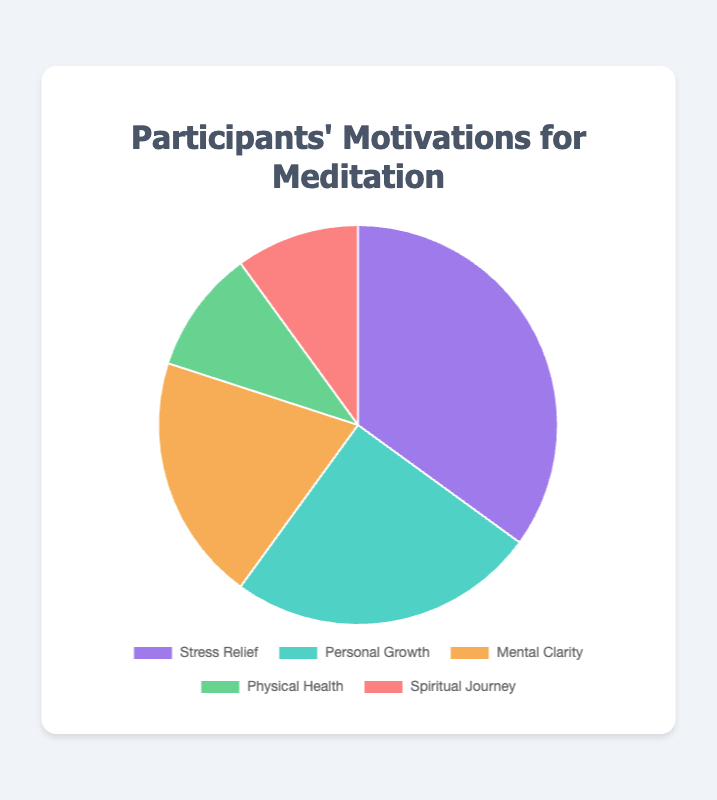What motivation has the highest percentage? The figure shows the pie chart with percentages; Stress Relief holds the largest section of the pie at 35%.
Answer: Stress Relief Which two motivations have the same percentage? The pie chart shows two slices of equal size at 10%, labeled Physical Health and Spiritual Journey.
Answer: Physical Health and Spiritual Journey What is the total percentage of participants motivated by either Stress Relief or Personal Growth? Adding the percentages for Stress Relief (35%) and Personal Growth (25%) gives 35 + 25 = 60.
Answer: 60% What is the difference in the percentage between Personal Growth and Mental Clarity? Substract the percentage for Mental Clarity (20%) from Personal Growth (25%) to get 25 - 20 = 5.
Answer: 5% What colors represent the motivations of Physical Health and Spiritual Journey? The visual attributes show that Physical Health is represented by green, and Spiritual Journey by red.
Answer: Green and Red How much larger is the Stress Relief percentage compared to Physical Health? Subtract the percentage of Physical Health (10%) from Stress Relief (35%) to get 35 - 10 = 25.
Answer: 25% If you sum the percentages of Mental Clarity, Physical Health, and Spiritual Journey, what do you get? Adding the percentages of Mental Clarity (20%), Physical Health (10%), and Spiritual Journey (10%) gives 20 + 10 + 10 = 40.
Answer: 40% Which motivation is represented by the orange slice? From the visual attributes, the pie chart shows that the orange slice corresponds to Mental Clarity.
Answer: Mental Clarity Arrange the motivations in descending order of their percentages. Listing the motivations based on their percentages from highest to lowest: Stress Relief (35%), Personal Growth (25%), Mental Clarity (20%), Physical Health (10%), Spiritual Journey (10%).
Answer: Stress Relief, Personal Growth, Mental Clarity, Physical Health, Spiritual Journey Among the given motivations, which two have the smallest percentage, and what is their combined total? The pie chart shows that Physical Health and Spiritual Journey both have the smallest percentage of 10%, their combined total is 10 + 10 = 20.
Answer: Physical Health and Spiritual Journey, 20% 